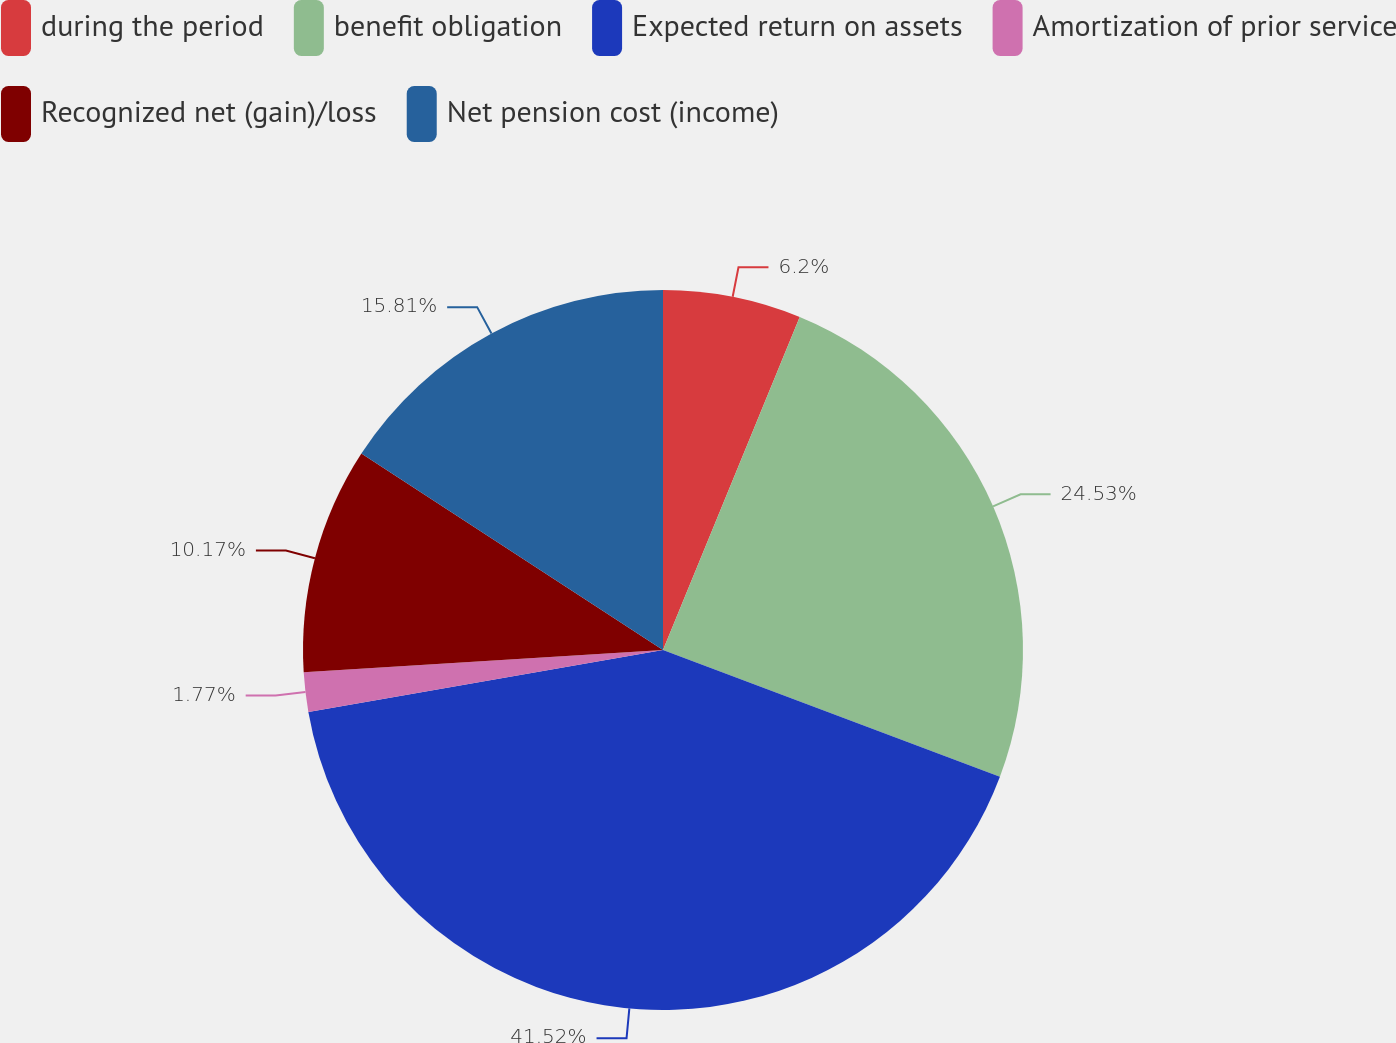<chart> <loc_0><loc_0><loc_500><loc_500><pie_chart><fcel>during the period<fcel>benefit obligation<fcel>Expected return on assets<fcel>Amortization of prior service<fcel>Recognized net (gain)/loss<fcel>Net pension cost (income)<nl><fcel>6.2%<fcel>24.53%<fcel>41.52%<fcel>1.77%<fcel>10.17%<fcel>15.81%<nl></chart> 